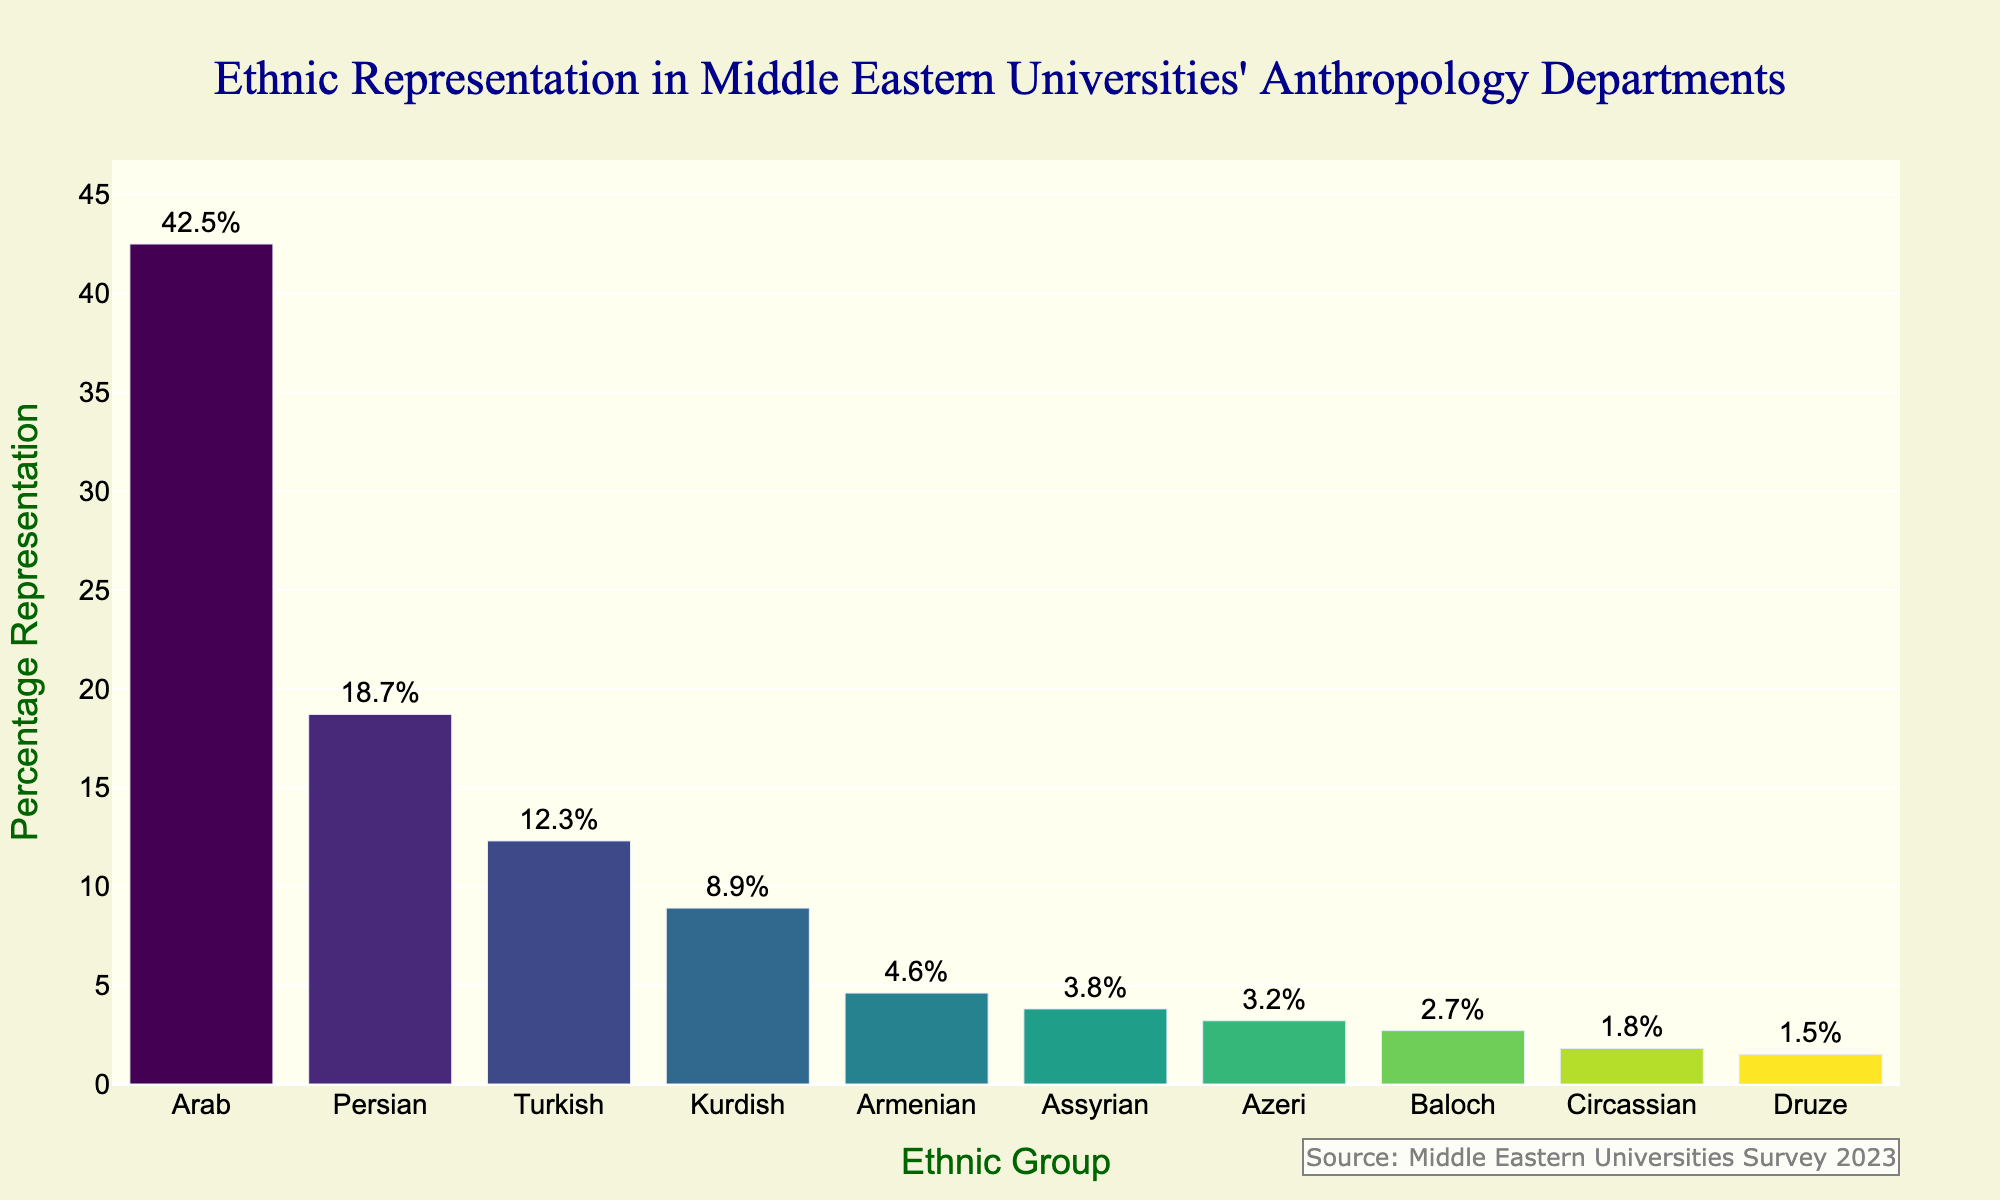Which ethnic group has the highest percentage representation in Middle Eastern universities' anthropology departments? To determine the ethnic group with the highest percentage representation, examine the bar lengths and corresponding percentages. The Arab group has the tallest bar with 42.5%.
Answer: Arab Which ethnic group has the lowest percentage representation? Look for the shortest bar on the chart, which corresponds to the smallest percentage. The Druze group has the shortest bar with 1.5%.
Answer: Druze Compare the representation of the Armenian and Assyrian ethnic groups. Which group has a higher representation, and by how much? Find the difference between the percentages of the two ethnic groups. The Armenian group has 4.6%, while the Assyrian group has 3.8%. The difference is 4.6% - 3.8% = 0.8%.
Answer: Armenian by 0.8% What is the total percentage representation of the top three ethnic groups? Add the percentages of the Arab (42.5%), Persian (18.7%), and Turkish (12.3%) groups. The total is 42.5% + 18.7% + 12.3% = 73.5%.
Answer: 73.5% How much more represented is the Turkish group compared to the Circassian group? Subtract the percentage of the Circassian group (1.8%) from the Turkish group (12.3%). The difference is 12.3% - 1.8% = 10.5%.
Answer: 10.5% What is the average representation of the four smallest ethnic groups? Sum the percentages of the four smallest groups (Circassian 1.8%, Druze 1.5%, Azeri 3.2%, Baloch 2.7%), then divide by 4. The total is 1.8% + 1.5% + 3.2% + 2.7% = 9.2%. The average is 9.2% / 4 = 2.3%.
Answer: 2.3% Which ethnic group is represented more than twice that of the Kurdish group? The Kurdish group has 8.9%. To find if any group is more than twice that, we compare 8.9% * 2 = 17.8%. Both Arab (42.5%) and Persian (18.7%) groups meet this condition.
Answer: Arab, Persian Is the representation of the Persian ethnic group more than the combined representation of the Armenian and Baloch groups? Add the percentages of the Armenian (4.6%) and Baloch (2.7%) groups, which gives 4.6% + 2.7% = 7.3%. Compare this to the Persian group's representation of 18.7%. 18.7% > 7.3%.
Answer: Yes What is the combined percentage representation of the Kurdish and Azeri ethnic groups? Add the percentages of the Kurdish (8.9%) and Azeri (3.2%) groups. The total is 8.9% + 3.2% = 12.1%.
Answer: 12.1% 